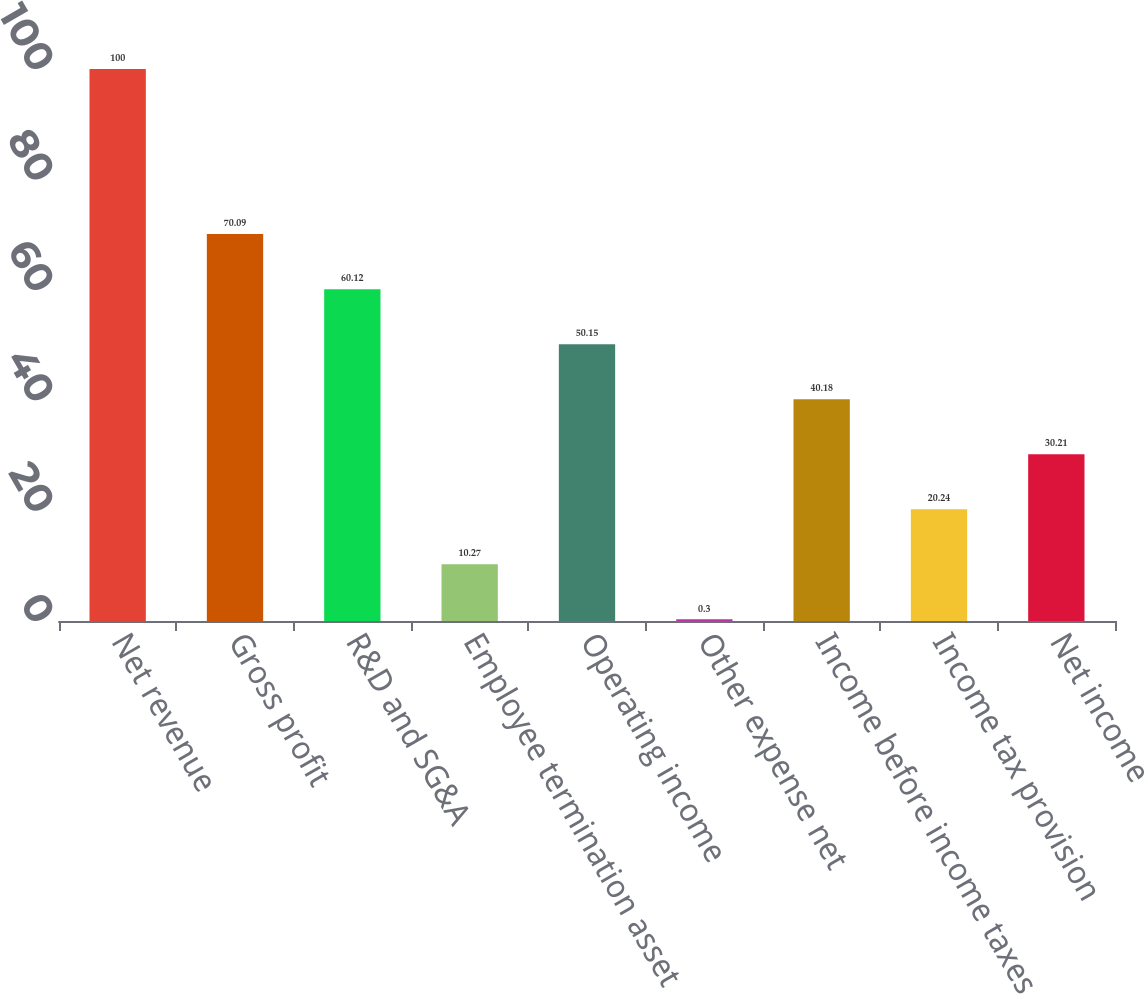Convert chart. <chart><loc_0><loc_0><loc_500><loc_500><bar_chart><fcel>Net revenue<fcel>Gross profit<fcel>R&D and SG&A<fcel>Employee termination asset<fcel>Operating income<fcel>Other expense net<fcel>Income before income taxes<fcel>Income tax provision<fcel>Net income<nl><fcel>100<fcel>70.09<fcel>60.12<fcel>10.27<fcel>50.15<fcel>0.3<fcel>40.18<fcel>20.24<fcel>30.21<nl></chart> 